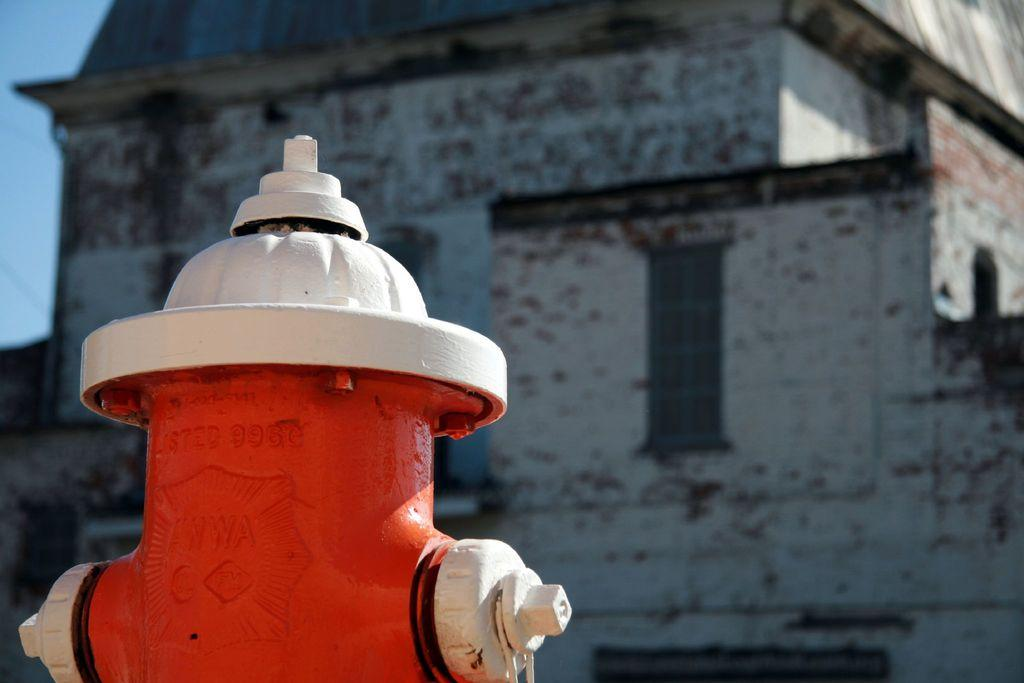What type of structure is present in the image? There is a building in the image. What feature can be seen on the building? The building has windows. What object is located near the building? There is a hydrant in the image. What can be seen in the background of the image? The sky is visible in the background of the image. How many minutes does the bird take to fly across the image? There is no bird present in the image, so it is not possible to determine how long it would take for a bird to fly across the image. 